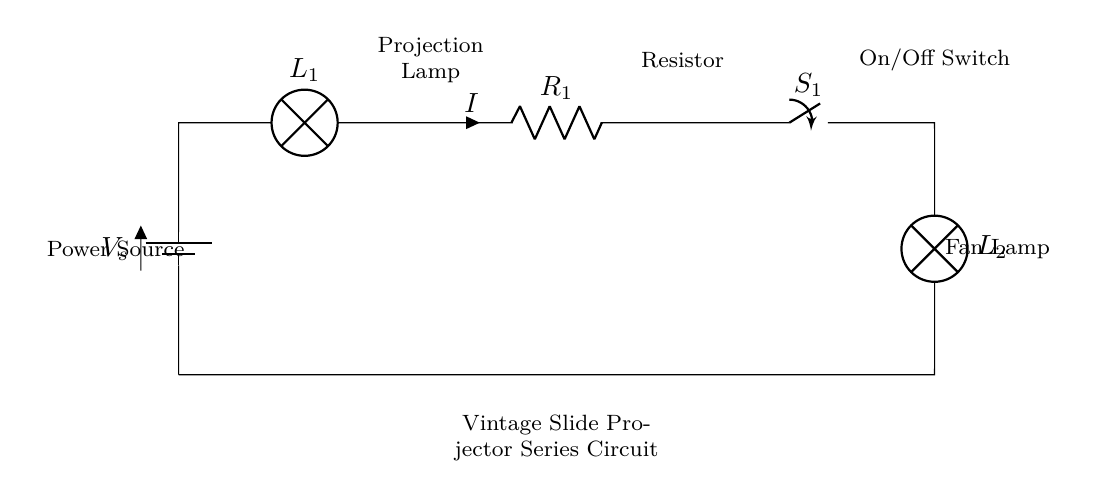What is the main power source for this circuit? The circuit diagram includes one power source indicated as a battery, labeled V_s at the left side of the diagram.
Answer: battery What component is labeled as L1 in the circuit? L1 is labeled as a lamp, which is indicated to be used for projection. It is located next to the power source.
Answer: Projection lamp What is the role of the resistor labeled R1? R1 is a resistor that is part of the series circuit; it limits the current flowing through the circuit. It is located after the projection lamp in the sequence.
Answer: Current limiter How many lamps are present in this circuit? There are two lamps shown in the circuit diagram: L1 (projection lamp) and L2 (fan lamp). They are both part of the series configuration.
Answer: two What state is the switch labeled S1 in the diagram? The switch S1 is labeled without any state indicators, but if we consider a functional circuit, it can be either open or closed based on its usage.
Answer: unknown What will happen if the switch S1 is open? If S1 is open, the circuit will be incomplete, and no current will flow through the lamps or resistor, causing the lamps to turn off.
Answer: lamps off Why is the circuit classified as a series circuit? The circuit is classified as a series circuit because all components, including the power source, lamps, resistor, and switch, are connected in a single path, allowing current to flow through each component sequentially.
Answer: single path 